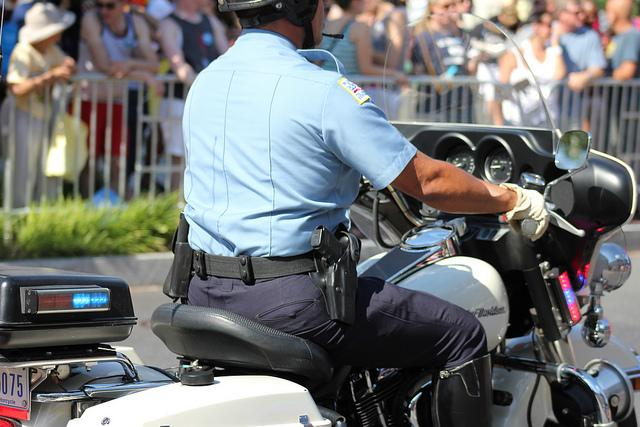What part of the cops uniform has the most similar theme to the motorcycle? pants 